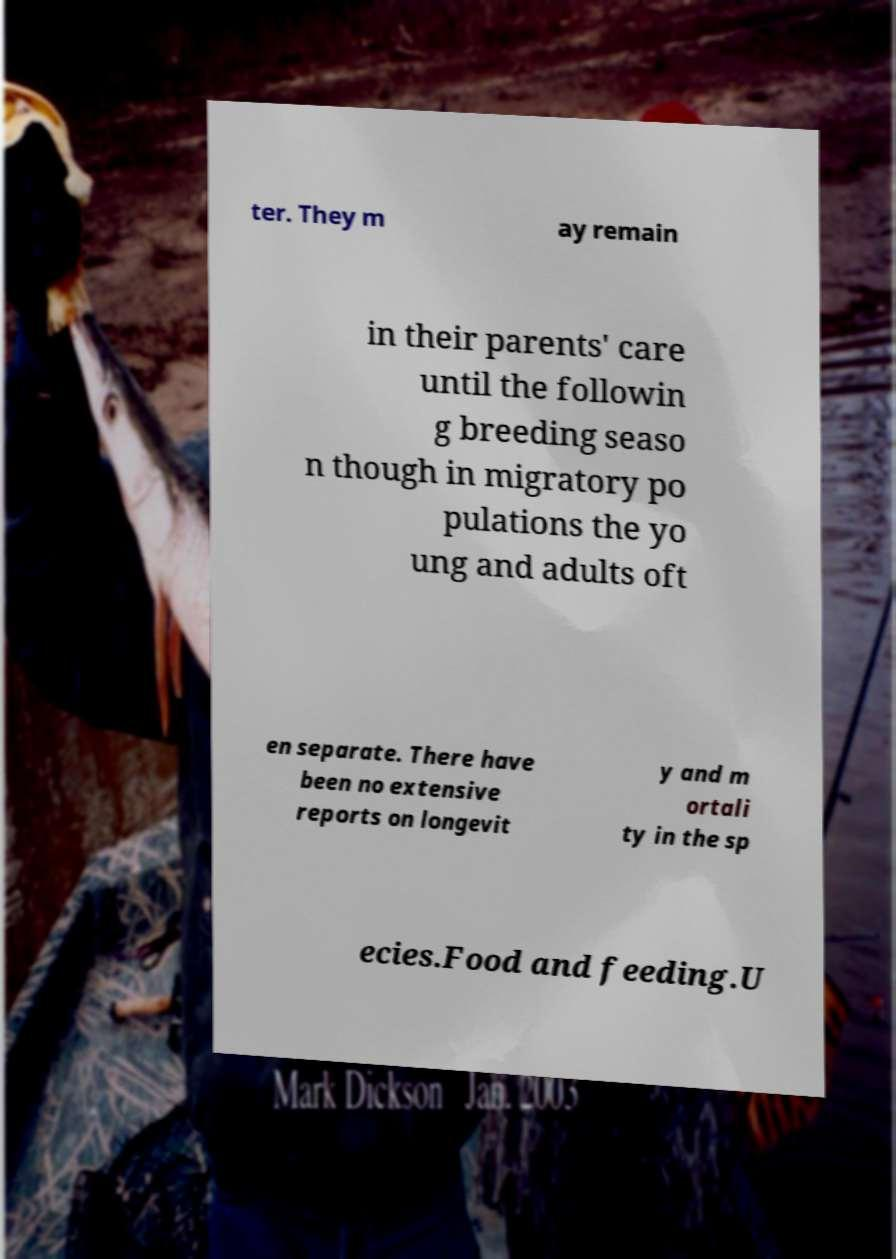For documentation purposes, I need the text within this image transcribed. Could you provide that? ter. They m ay remain in their parents' care until the followin g breeding seaso n though in migratory po pulations the yo ung and adults oft en separate. There have been no extensive reports on longevit y and m ortali ty in the sp ecies.Food and feeding.U 